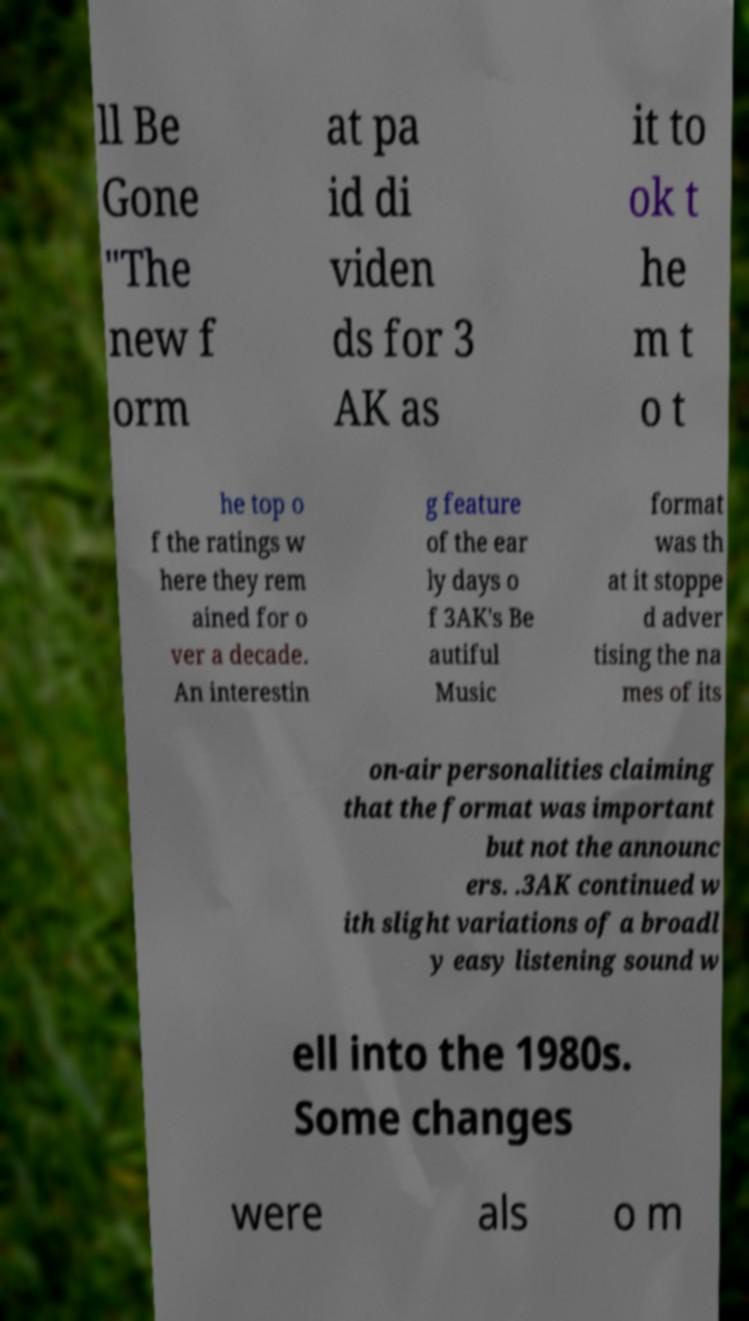Please read and relay the text visible in this image. What does it say? ll Be Gone "The new f orm at pa id di viden ds for 3 AK as it to ok t he m t o t he top o f the ratings w here they rem ained for o ver a decade. An interestin g feature of the ear ly days o f 3AK's Be autiful Music format was th at it stoppe d adver tising the na mes of its on-air personalities claiming that the format was important but not the announc ers. .3AK continued w ith slight variations of a broadl y easy listening sound w ell into the 1980s. Some changes were als o m 